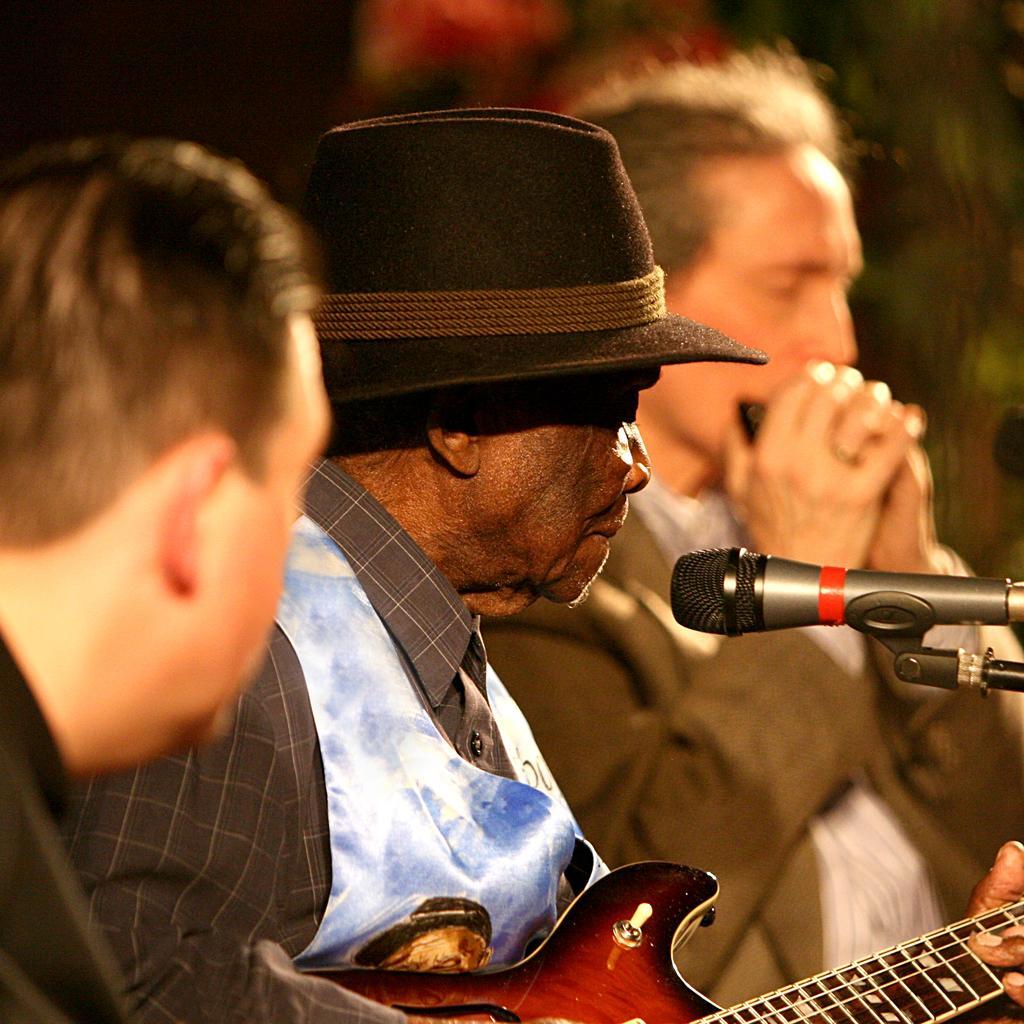How would you summarize this image in a sentence or two? In this picture there is a man playing a guitar. There is also another person playing a musical instrument. There is also another person to the left. 